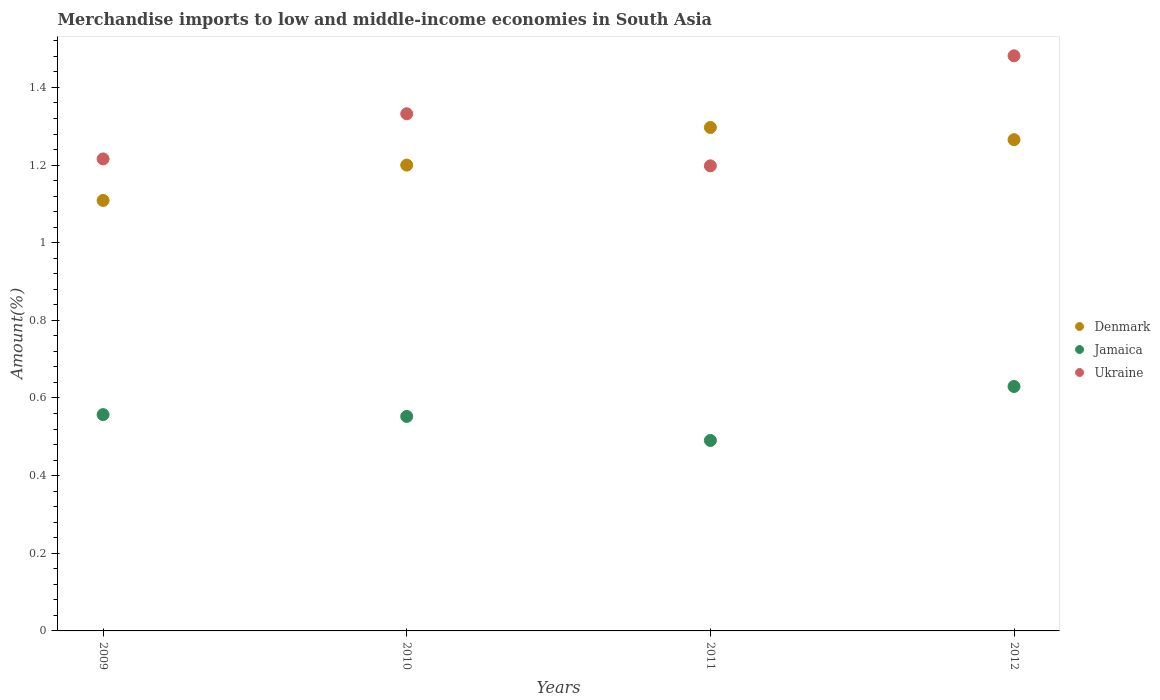What is the percentage of amount earned from merchandise imports in Denmark in 2009?
Provide a short and direct response. 1.11. Across all years, what is the maximum percentage of amount earned from merchandise imports in Ukraine?
Ensure brevity in your answer.  1.48. Across all years, what is the minimum percentage of amount earned from merchandise imports in Jamaica?
Make the answer very short. 0.49. In which year was the percentage of amount earned from merchandise imports in Ukraine maximum?
Your response must be concise. 2012. In which year was the percentage of amount earned from merchandise imports in Ukraine minimum?
Offer a very short reply. 2011. What is the total percentage of amount earned from merchandise imports in Jamaica in the graph?
Your response must be concise. 2.23. What is the difference between the percentage of amount earned from merchandise imports in Ukraine in 2010 and that in 2011?
Give a very brief answer. 0.13. What is the difference between the percentage of amount earned from merchandise imports in Ukraine in 2011 and the percentage of amount earned from merchandise imports in Jamaica in 2012?
Make the answer very short. 0.57. What is the average percentage of amount earned from merchandise imports in Jamaica per year?
Your answer should be compact. 0.56. In the year 2010, what is the difference between the percentage of amount earned from merchandise imports in Jamaica and percentage of amount earned from merchandise imports in Ukraine?
Your answer should be very brief. -0.78. What is the ratio of the percentage of amount earned from merchandise imports in Ukraine in 2010 to that in 2012?
Keep it short and to the point. 0.9. Is the percentage of amount earned from merchandise imports in Denmark in 2009 less than that in 2011?
Keep it short and to the point. Yes. What is the difference between the highest and the second highest percentage of amount earned from merchandise imports in Ukraine?
Provide a succinct answer. 0.15. What is the difference between the highest and the lowest percentage of amount earned from merchandise imports in Denmark?
Your answer should be compact. 0.19. Is it the case that in every year, the sum of the percentage of amount earned from merchandise imports in Denmark and percentage of amount earned from merchandise imports in Jamaica  is greater than the percentage of amount earned from merchandise imports in Ukraine?
Provide a short and direct response. Yes. Is the percentage of amount earned from merchandise imports in Denmark strictly less than the percentage of amount earned from merchandise imports in Ukraine over the years?
Ensure brevity in your answer.  No. How many years are there in the graph?
Give a very brief answer. 4. Are the values on the major ticks of Y-axis written in scientific E-notation?
Make the answer very short. No. Does the graph contain any zero values?
Your answer should be compact. No. Where does the legend appear in the graph?
Your answer should be very brief. Center right. What is the title of the graph?
Offer a terse response. Merchandise imports to low and middle-income economies in South Asia. Does "Israel" appear as one of the legend labels in the graph?
Provide a succinct answer. No. What is the label or title of the X-axis?
Provide a succinct answer. Years. What is the label or title of the Y-axis?
Your response must be concise. Amount(%). What is the Amount(%) of Denmark in 2009?
Your answer should be compact. 1.11. What is the Amount(%) in Jamaica in 2009?
Your answer should be compact. 0.56. What is the Amount(%) of Ukraine in 2009?
Provide a succinct answer. 1.22. What is the Amount(%) of Denmark in 2010?
Provide a succinct answer. 1.2. What is the Amount(%) in Jamaica in 2010?
Offer a terse response. 0.55. What is the Amount(%) in Ukraine in 2010?
Ensure brevity in your answer.  1.33. What is the Amount(%) of Denmark in 2011?
Give a very brief answer. 1.3. What is the Amount(%) of Jamaica in 2011?
Your response must be concise. 0.49. What is the Amount(%) of Ukraine in 2011?
Provide a succinct answer. 1.2. What is the Amount(%) in Denmark in 2012?
Offer a terse response. 1.27. What is the Amount(%) in Jamaica in 2012?
Provide a short and direct response. 0.63. What is the Amount(%) in Ukraine in 2012?
Your response must be concise. 1.48. Across all years, what is the maximum Amount(%) in Denmark?
Ensure brevity in your answer.  1.3. Across all years, what is the maximum Amount(%) in Jamaica?
Your answer should be compact. 0.63. Across all years, what is the maximum Amount(%) of Ukraine?
Keep it short and to the point. 1.48. Across all years, what is the minimum Amount(%) of Denmark?
Your answer should be compact. 1.11. Across all years, what is the minimum Amount(%) in Jamaica?
Provide a succinct answer. 0.49. Across all years, what is the minimum Amount(%) in Ukraine?
Give a very brief answer. 1.2. What is the total Amount(%) in Denmark in the graph?
Offer a terse response. 4.87. What is the total Amount(%) in Jamaica in the graph?
Keep it short and to the point. 2.23. What is the total Amount(%) of Ukraine in the graph?
Offer a terse response. 5.23. What is the difference between the Amount(%) of Denmark in 2009 and that in 2010?
Make the answer very short. -0.09. What is the difference between the Amount(%) of Jamaica in 2009 and that in 2010?
Make the answer very short. 0. What is the difference between the Amount(%) in Ukraine in 2009 and that in 2010?
Keep it short and to the point. -0.12. What is the difference between the Amount(%) of Denmark in 2009 and that in 2011?
Make the answer very short. -0.19. What is the difference between the Amount(%) in Jamaica in 2009 and that in 2011?
Keep it short and to the point. 0.07. What is the difference between the Amount(%) of Ukraine in 2009 and that in 2011?
Ensure brevity in your answer.  0.02. What is the difference between the Amount(%) in Denmark in 2009 and that in 2012?
Give a very brief answer. -0.16. What is the difference between the Amount(%) of Jamaica in 2009 and that in 2012?
Keep it short and to the point. -0.07. What is the difference between the Amount(%) of Ukraine in 2009 and that in 2012?
Ensure brevity in your answer.  -0.27. What is the difference between the Amount(%) of Denmark in 2010 and that in 2011?
Offer a very short reply. -0.1. What is the difference between the Amount(%) in Jamaica in 2010 and that in 2011?
Offer a terse response. 0.06. What is the difference between the Amount(%) of Ukraine in 2010 and that in 2011?
Your answer should be compact. 0.13. What is the difference between the Amount(%) of Denmark in 2010 and that in 2012?
Give a very brief answer. -0.07. What is the difference between the Amount(%) of Jamaica in 2010 and that in 2012?
Offer a terse response. -0.08. What is the difference between the Amount(%) of Ukraine in 2010 and that in 2012?
Your answer should be very brief. -0.15. What is the difference between the Amount(%) of Denmark in 2011 and that in 2012?
Give a very brief answer. 0.03. What is the difference between the Amount(%) in Jamaica in 2011 and that in 2012?
Provide a succinct answer. -0.14. What is the difference between the Amount(%) in Ukraine in 2011 and that in 2012?
Offer a terse response. -0.28. What is the difference between the Amount(%) of Denmark in 2009 and the Amount(%) of Jamaica in 2010?
Offer a very short reply. 0.56. What is the difference between the Amount(%) of Denmark in 2009 and the Amount(%) of Ukraine in 2010?
Ensure brevity in your answer.  -0.22. What is the difference between the Amount(%) of Jamaica in 2009 and the Amount(%) of Ukraine in 2010?
Your answer should be very brief. -0.78. What is the difference between the Amount(%) of Denmark in 2009 and the Amount(%) of Jamaica in 2011?
Ensure brevity in your answer.  0.62. What is the difference between the Amount(%) in Denmark in 2009 and the Amount(%) in Ukraine in 2011?
Give a very brief answer. -0.09. What is the difference between the Amount(%) in Jamaica in 2009 and the Amount(%) in Ukraine in 2011?
Your answer should be very brief. -0.64. What is the difference between the Amount(%) in Denmark in 2009 and the Amount(%) in Jamaica in 2012?
Your answer should be very brief. 0.48. What is the difference between the Amount(%) of Denmark in 2009 and the Amount(%) of Ukraine in 2012?
Your answer should be compact. -0.37. What is the difference between the Amount(%) in Jamaica in 2009 and the Amount(%) in Ukraine in 2012?
Offer a terse response. -0.92. What is the difference between the Amount(%) in Denmark in 2010 and the Amount(%) in Jamaica in 2011?
Make the answer very short. 0.71. What is the difference between the Amount(%) in Denmark in 2010 and the Amount(%) in Ukraine in 2011?
Keep it short and to the point. 0. What is the difference between the Amount(%) in Jamaica in 2010 and the Amount(%) in Ukraine in 2011?
Offer a terse response. -0.65. What is the difference between the Amount(%) of Denmark in 2010 and the Amount(%) of Jamaica in 2012?
Ensure brevity in your answer.  0.57. What is the difference between the Amount(%) in Denmark in 2010 and the Amount(%) in Ukraine in 2012?
Keep it short and to the point. -0.28. What is the difference between the Amount(%) of Jamaica in 2010 and the Amount(%) of Ukraine in 2012?
Your answer should be compact. -0.93. What is the difference between the Amount(%) in Denmark in 2011 and the Amount(%) in Jamaica in 2012?
Make the answer very short. 0.67. What is the difference between the Amount(%) of Denmark in 2011 and the Amount(%) of Ukraine in 2012?
Offer a very short reply. -0.18. What is the difference between the Amount(%) in Jamaica in 2011 and the Amount(%) in Ukraine in 2012?
Provide a succinct answer. -0.99. What is the average Amount(%) in Denmark per year?
Provide a succinct answer. 1.22. What is the average Amount(%) in Jamaica per year?
Offer a terse response. 0.56. What is the average Amount(%) in Ukraine per year?
Your answer should be compact. 1.31. In the year 2009, what is the difference between the Amount(%) in Denmark and Amount(%) in Jamaica?
Ensure brevity in your answer.  0.55. In the year 2009, what is the difference between the Amount(%) of Denmark and Amount(%) of Ukraine?
Provide a succinct answer. -0.11. In the year 2009, what is the difference between the Amount(%) in Jamaica and Amount(%) in Ukraine?
Provide a succinct answer. -0.66. In the year 2010, what is the difference between the Amount(%) in Denmark and Amount(%) in Jamaica?
Offer a very short reply. 0.65. In the year 2010, what is the difference between the Amount(%) of Denmark and Amount(%) of Ukraine?
Give a very brief answer. -0.13. In the year 2010, what is the difference between the Amount(%) of Jamaica and Amount(%) of Ukraine?
Give a very brief answer. -0.78. In the year 2011, what is the difference between the Amount(%) of Denmark and Amount(%) of Jamaica?
Make the answer very short. 0.81. In the year 2011, what is the difference between the Amount(%) in Denmark and Amount(%) in Ukraine?
Keep it short and to the point. 0.1. In the year 2011, what is the difference between the Amount(%) of Jamaica and Amount(%) of Ukraine?
Your answer should be compact. -0.71. In the year 2012, what is the difference between the Amount(%) of Denmark and Amount(%) of Jamaica?
Offer a very short reply. 0.64. In the year 2012, what is the difference between the Amount(%) of Denmark and Amount(%) of Ukraine?
Your response must be concise. -0.22. In the year 2012, what is the difference between the Amount(%) of Jamaica and Amount(%) of Ukraine?
Make the answer very short. -0.85. What is the ratio of the Amount(%) in Denmark in 2009 to that in 2010?
Ensure brevity in your answer.  0.92. What is the ratio of the Amount(%) of Jamaica in 2009 to that in 2010?
Your response must be concise. 1.01. What is the ratio of the Amount(%) of Ukraine in 2009 to that in 2010?
Provide a short and direct response. 0.91. What is the ratio of the Amount(%) of Denmark in 2009 to that in 2011?
Provide a short and direct response. 0.85. What is the ratio of the Amount(%) in Jamaica in 2009 to that in 2011?
Make the answer very short. 1.14. What is the ratio of the Amount(%) in Ukraine in 2009 to that in 2011?
Offer a very short reply. 1.01. What is the ratio of the Amount(%) of Denmark in 2009 to that in 2012?
Make the answer very short. 0.88. What is the ratio of the Amount(%) of Jamaica in 2009 to that in 2012?
Keep it short and to the point. 0.88. What is the ratio of the Amount(%) in Ukraine in 2009 to that in 2012?
Provide a succinct answer. 0.82. What is the ratio of the Amount(%) of Denmark in 2010 to that in 2011?
Make the answer very short. 0.93. What is the ratio of the Amount(%) in Jamaica in 2010 to that in 2011?
Your answer should be very brief. 1.13. What is the ratio of the Amount(%) in Ukraine in 2010 to that in 2011?
Provide a succinct answer. 1.11. What is the ratio of the Amount(%) of Denmark in 2010 to that in 2012?
Offer a terse response. 0.95. What is the ratio of the Amount(%) of Jamaica in 2010 to that in 2012?
Provide a short and direct response. 0.88. What is the ratio of the Amount(%) in Ukraine in 2010 to that in 2012?
Your response must be concise. 0.9. What is the ratio of the Amount(%) of Denmark in 2011 to that in 2012?
Provide a succinct answer. 1.02. What is the ratio of the Amount(%) of Jamaica in 2011 to that in 2012?
Offer a terse response. 0.78. What is the ratio of the Amount(%) of Ukraine in 2011 to that in 2012?
Ensure brevity in your answer.  0.81. What is the difference between the highest and the second highest Amount(%) of Denmark?
Offer a very short reply. 0.03. What is the difference between the highest and the second highest Amount(%) in Jamaica?
Make the answer very short. 0.07. What is the difference between the highest and the second highest Amount(%) of Ukraine?
Ensure brevity in your answer.  0.15. What is the difference between the highest and the lowest Amount(%) of Denmark?
Give a very brief answer. 0.19. What is the difference between the highest and the lowest Amount(%) in Jamaica?
Provide a succinct answer. 0.14. What is the difference between the highest and the lowest Amount(%) in Ukraine?
Your response must be concise. 0.28. 